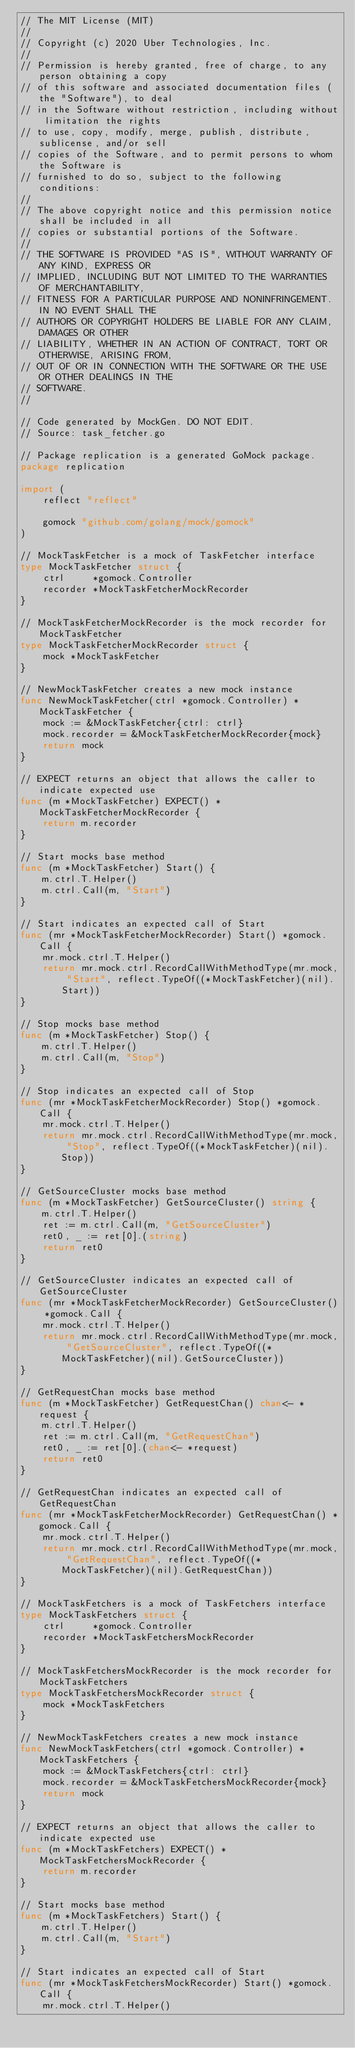Convert code to text. <code><loc_0><loc_0><loc_500><loc_500><_Go_>// The MIT License (MIT)
//
// Copyright (c) 2020 Uber Technologies, Inc.
//
// Permission is hereby granted, free of charge, to any person obtaining a copy
// of this software and associated documentation files (the "Software"), to deal
// in the Software without restriction, including without limitation the rights
// to use, copy, modify, merge, publish, distribute, sublicense, and/or sell
// copies of the Software, and to permit persons to whom the Software is
// furnished to do so, subject to the following conditions:
//
// The above copyright notice and this permission notice shall be included in all
// copies or substantial portions of the Software.
//
// THE SOFTWARE IS PROVIDED "AS IS", WITHOUT WARRANTY OF ANY KIND, EXPRESS OR
// IMPLIED, INCLUDING BUT NOT LIMITED TO THE WARRANTIES OF MERCHANTABILITY,
// FITNESS FOR A PARTICULAR PURPOSE AND NONINFRINGEMENT. IN NO EVENT SHALL THE
// AUTHORS OR COPYRIGHT HOLDERS BE LIABLE FOR ANY CLAIM, DAMAGES OR OTHER
// LIABILITY, WHETHER IN AN ACTION OF CONTRACT, TORT OR OTHERWISE, ARISING FROM,
// OUT OF OR IN CONNECTION WITH THE SOFTWARE OR THE USE OR OTHER DEALINGS IN THE
// SOFTWARE.
//

// Code generated by MockGen. DO NOT EDIT.
// Source: task_fetcher.go

// Package replication is a generated GoMock package.
package replication

import (
	reflect "reflect"

	gomock "github.com/golang/mock/gomock"
)

// MockTaskFetcher is a mock of TaskFetcher interface
type MockTaskFetcher struct {
	ctrl     *gomock.Controller
	recorder *MockTaskFetcherMockRecorder
}

// MockTaskFetcherMockRecorder is the mock recorder for MockTaskFetcher
type MockTaskFetcherMockRecorder struct {
	mock *MockTaskFetcher
}

// NewMockTaskFetcher creates a new mock instance
func NewMockTaskFetcher(ctrl *gomock.Controller) *MockTaskFetcher {
	mock := &MockTaskFetcher{ctrl: ctrl}
	mock.recorder = &MockTaskFetcherMockRecorder{mock}
	return mock
}

// EXPECT returns an object that allows the caller to indicate expected use
func (m *MockTaskFetcher) EXPECT() *MockTaskFetcherMockRecorder {
	return m.recorder
}

// Start mocks base method
func (m *MockTaskFetcher) Start() {
	m.ctrl.T.Helper()
	m.ctrl.Call(m, "Start")
}

// Start indicates an expected call of Start
func (mr *MockTaskFetcherMockRecorder) Start() *gomock.Call {
	mr.mock.ctrl.T.Helper()
	return mr.mock.ctrl.RecordCallWithMethodType(mr.mock, "Start", reflect.TypeOf((*MockTaskFetcher)(nil).Start))
}

// Stop mocks base method
func (m *MockTaskFetcher) Stop() {
	m.ctrl.T.Helper()
	m.ctrl.Call(m, "Stop")
}

// Stop indicates an expected call of Stop
func (mr *MockTaskFetcherMockRecorder) Stop() *gomock.Call {
	mr.mock.ctrl.T.Helper()
	return mr.mock.ctrl.RecordCallWithMethodType(mr.mock, "Stop", reflect.TypeOf((*MockTaskFetcher)(nil).Stop))
}

// GetSourceCluster mocks base method
func (m *MockTaskFetcher) GetSourceCluster() string {
	m.ctrl.T.Helper()
	ret := m.ctrl.Call(m, "GetSourceCluster")
	ret0, _ := ret[0].(string)
	return ret0
}

// GetSourceCluster indicates an expected call of GetSourceCluster
func (mr *MockTaskFetcherMockRecorder) GetSourceCluster() *gomock.Call {
	mr.mock.ctrl.T.Helper()
	return mr.mock.ctrl.RecordCallWithMethodType(mr.mock, "GetSourceCluster", reflect.TypeOf((*MockTaskFetcher)(nil).GetSourceCluster))
}

// GetRequestChan mocks base method
func (m *MockTaskFetcher) GetRequestChan() chan<- *request {
	m.ctrl.T.Helper()
	ret := m.ctrl.Call(m, "GetRequestChan")
	ret0, _ := ret[0].(chan<- *request)
	return ret0
}

// GetRequestChan indicates an expected call of GetRequestChan
func (mr *MockTaskFetcherMockRecorder) GetRequestChan() *gomock.Call {
	mr.mock.ctrl.T.Helper()
	return mr.mock.ctrl.RecordCallWithMethodType(mr.mock, "GetRequestChan", reflect.TypeOf((*MockTaskFetcher)(nil).GetRequestChan))
}

// MockTaskFetchers is a mock of TaskFetchers interface
type MockTaskFetchers struct {
	ctrl     *gomock.Controller
	recorder *MockTaskFetchersMockRecorder
}

// MockTaskFetchersMockRecorder is the mock recorder for MockTaskFetchers
type MockTaskFetchersMockRecorder struct {
	mock *MockTaskFetchers
}

// NewMockTaskFetchers creates a new mock instance
func NewMockTaskFetchers(ctrl *gomock.Controller) *MockTaskFetchers {
	mock := &MockTaskFetchers{ctrl: ctrl}
	mock.recorder = &MockTaskFetchersMockRecorder{mock}
	return mock
}

// EXPECT returns an object that allows the caller to indicate expected use
func (m *MockTaskFetchers) EXPECT() *MockTaskFetchersMockRecorder {
	return m.recorder
}

// Start mocks base method
func (m *MockTaskFetchers) Start() {
	m.ctrl.T.Helper()
	m.ctrl.Call(m, "Start")
}

// Start indicates an expected call of Start
func (mr *MockTaskFetchersMockRecorder) Start() *gomock.Call {
	mr.mock.ctrl.T.Helper()</code> 